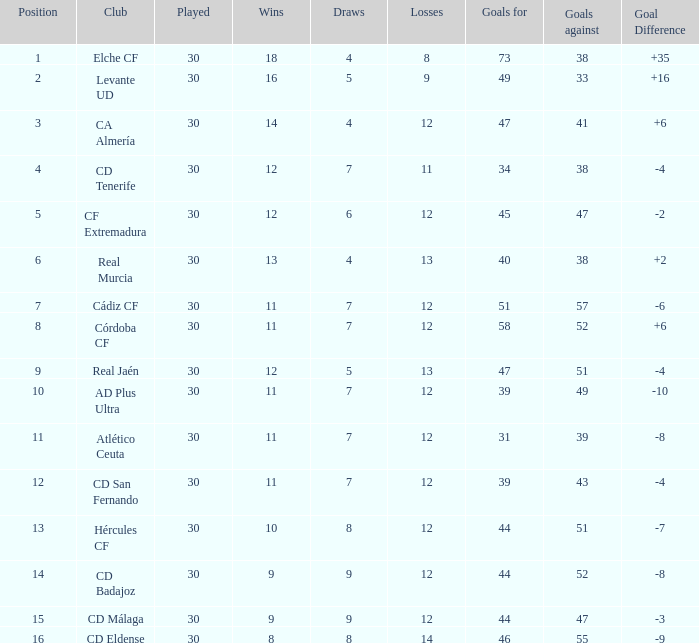What is the lowest amount of draws with less than 12 wins and less than 30 played? None. 